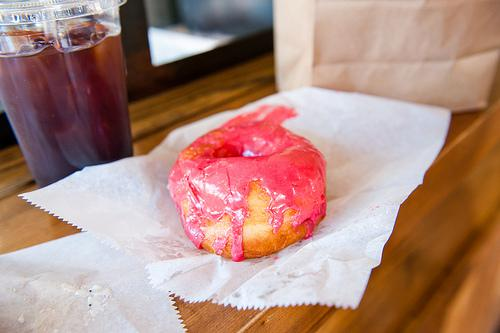Question: where is the doughnut?
Choices:
A. In a box.
B. On a plate.
C. On a napkin.
D. On a piece of paper.
Answer with the letter. Answer: D Question: why is the doughnut on paper?
Choices:
A. As a plate.
B. To keep the table clean.
C. To not drop crumbs.
D. For personal cleanliness.
Answer with the letter. Answer: B Question: who made the doughnut?
Choices:
A. My aunt.
B. A cook.
C. A chef.
D. A cousin.
Answer with the letter. Answer: B Question: what is in the background?
Choices:
A. A cup of soda.
B. A tree.
C. Hills.
D. A beach.
Answer with the letter. Answer: A Question: how many doughnuts are there?
Choices:
A. Two.
B. One.
C. Three.
D. Four.
Answer with the letter. Answer: B Question: what color is the bag?
Choices:
A. Black.
B. White.
C. Red.
D. Brown.
Answer with the letter. Answer: D 